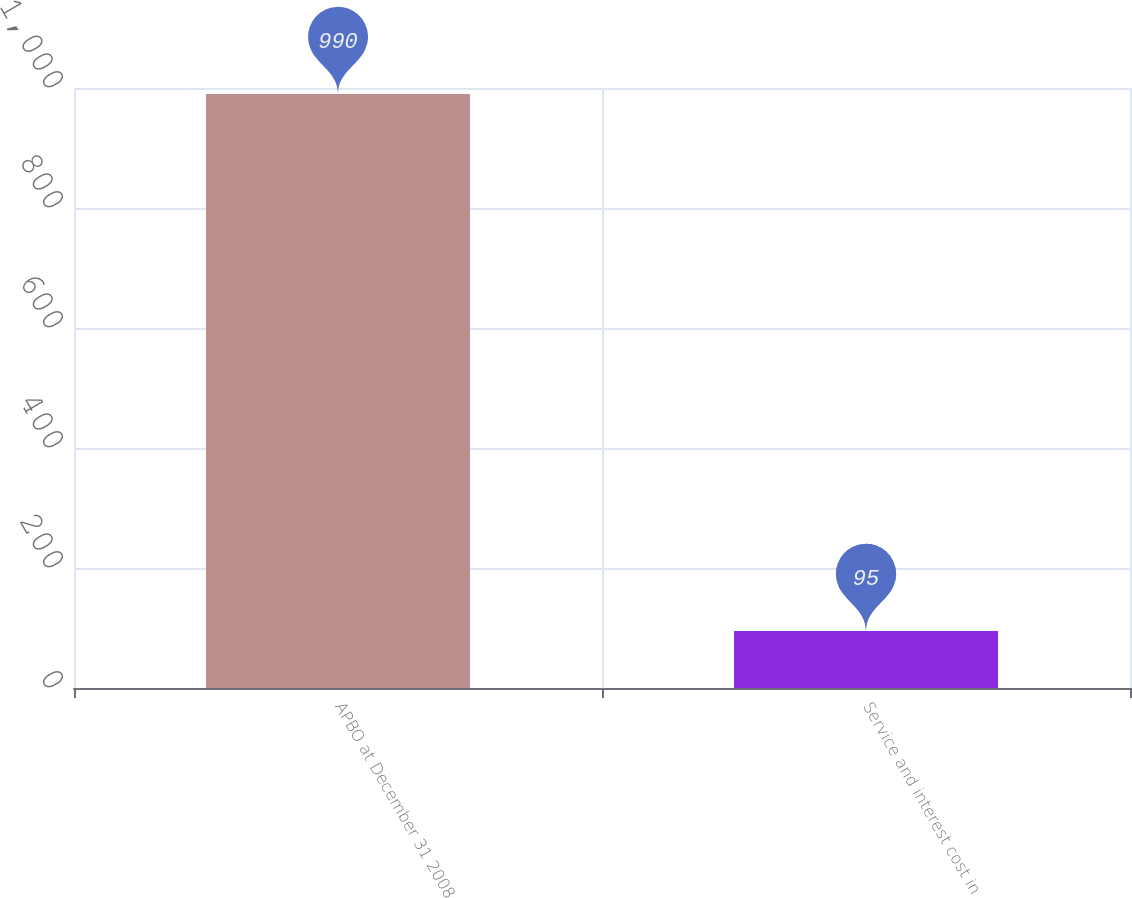Convert chart to OTSL. <chart><loc_0><loc_0><loc_500><loc_500><bar_chart><fcel>APBO at December 31 2008<fcel>Service and interest cost in<nl><fcel>990<fcel>95<nl></chart> 